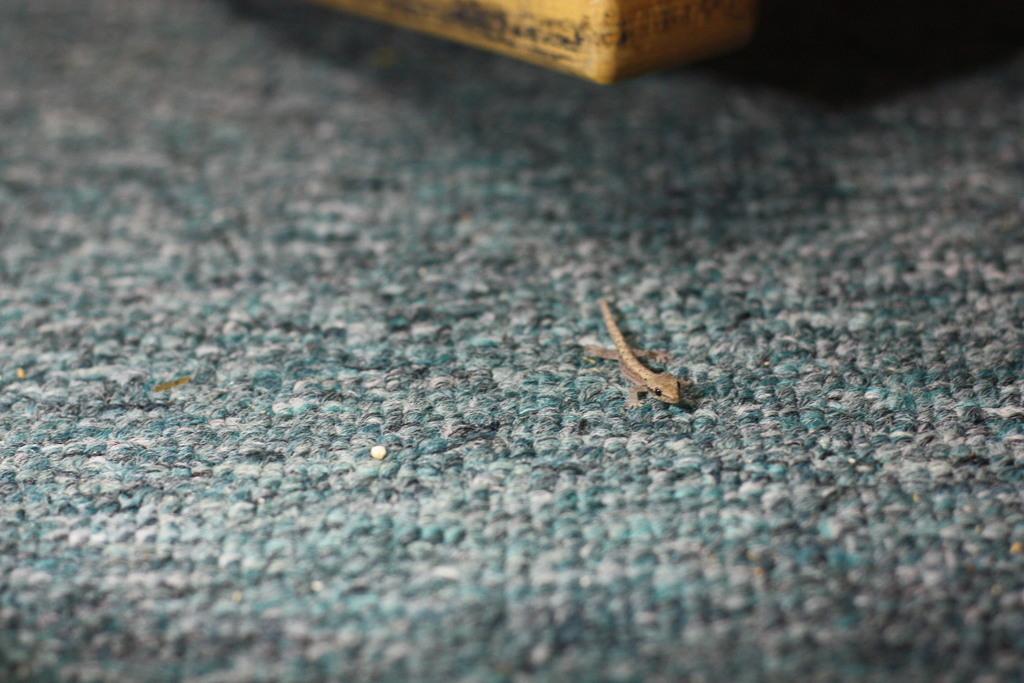Can you describe this image briefly? Here we can see a lizard present on the floor. 